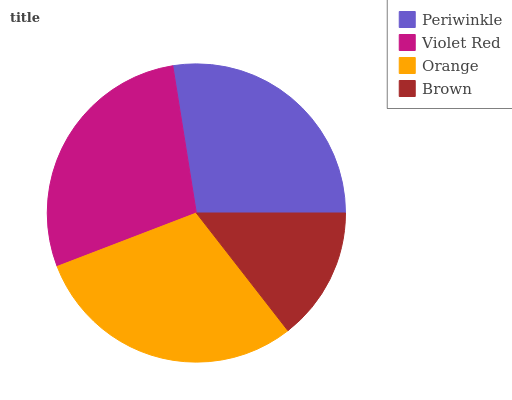Is Brown the minimum?
Answer yes or no. Yes. Is Orange the maximum?
Answer yes or no. Yes. Is Violet Red the minimum?
Answer yes or no. No. Is Violet Red the maximum?
Answer yes or no. No. Is Violet Red greater than Periwinkle?
Answer yes or no. Yes. Is Periwinkle less than Violet Red?
Answer yes or no. Yes. Is Periwinkle greater than Violet Red?
Answer yes or no. No. Is Violet Red less than Periwinkle?
Answer yes or no. No. Is Violet Red the high median?
Answer yes or no. Yes. Is Periwinkle the low median?
Answer yes or no. Yes. Is Periwinkle the high median?
Answer yes or no. No. Is Orange the low median?
Answer yes or no. No. 